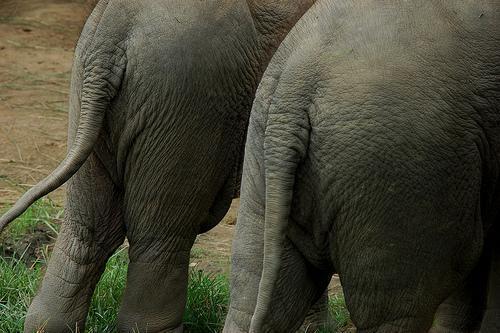How many set of legs?
Give a very brief answer. 2. 